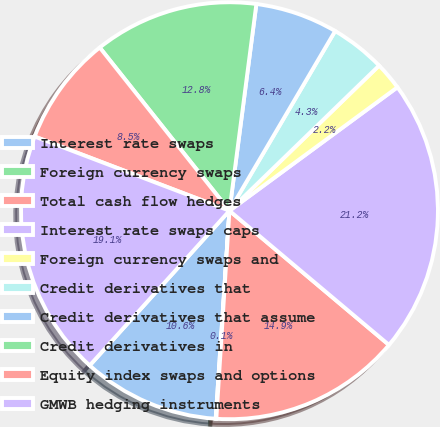Convert chart. <chart><loc_0><loc_0><loc_500><loc_500><pie_chart><fcel>Interest rate swaps<fcel>Foreign currency swaps<fcel>Total cash flow hedges<fcel>Interest rate swaps caps<fcel>Foreign currency swaps and<fcel>Credit derivatives that<fcel>Credit derivatives that assume<fcel>Credit derivatives in<fcel>Equity index swaps and options<fcel>GMWB hedging instruments<nl><fcel>10.64%<fcel>0.05%<fcel>14.87%<fcel>21.22%<fcel>2.17%<fcel>4.28%<fcel>6.4%<fcel>12.75%<fcel>8.52%<fcel>19.1%<nl></chart> 